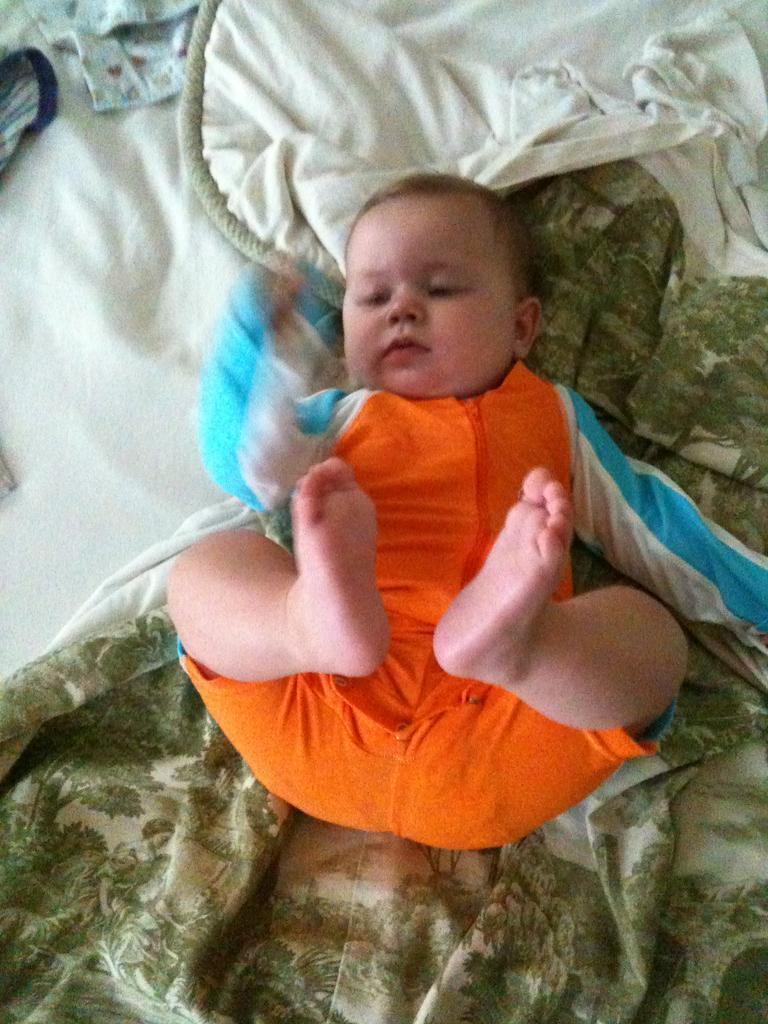In one or two sentences, can you explain what this image depicts? In this picture we can see a baby and clothes. 